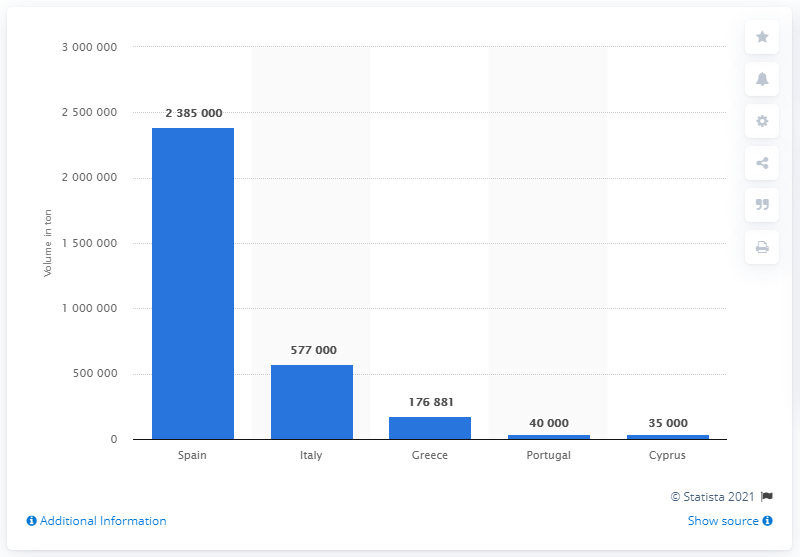List a handful of essential elements in this visual. In the 2018/2019 season, Spain produced a total of 238,500 metric tons of fresh tangerines. 